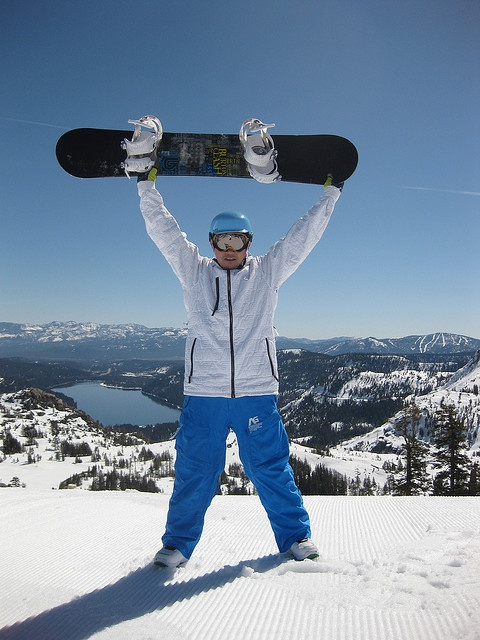Describe the objects in this image and their specific colors. I can see people in darkblue, darkgray, and blue tones and snowboard in darkblue, black, darkgray, gray, and navy tones in this image. 